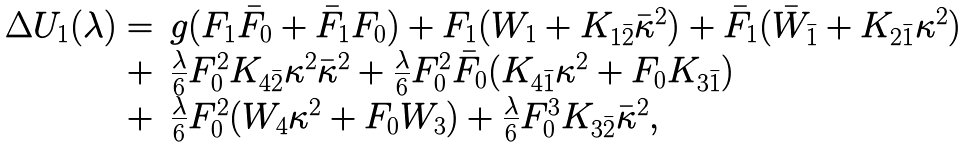Convert formula to latex. <formula><loc_0><loc_0><loc_500><loc_500>\begin{array} { r l } \Delta U _ { 1 } ( \lambda ) = & g ( F _ { 1 } \bar { F } _ { 0 } + \bar { F } _ { 1 } F _ { 0 } ) + F _ { 1 } ( W _ { 1 } + K _ { 1 \bar { 2 } } \bar { \kappa } ^ { 2 } ) + \bar { F } _ { 1 } ( \bar { W } _ { \bar { 1 } } + K _ { 2 \bar { 1 } } \kappa ^ { 2 } ) \\ + & \frac { \lambda } { 6 } F _ { 0 } ^ { 2 } K _ { 4 \bar { 2 } } \kappa ^ { 2 } \bar { \kappa } ^ { 2 } + \frac { \lambda } { 6 } F _ { 0 } ^ { 2 } \bar { F } _ { 0 } ( K _ { 4 \bar { 1 } } \kappa ^ { 2 } + F _ { 0 } K _ { 3 \bar { 1 } } ) \\ + & \frac { \lambda } { 6 } F _ { 0 } ^ { 2 } ( W _ { 4 } \kappa ^ { 2 } + F _ { 0 } W _ { 3 } ) + \frac { \lambda } { 6 } F _ { 0 } ^ { 3 } K _ { 3 \bar { 2 } } \bar { \kappa } ^ { 2 } , \end{array}</formula> 